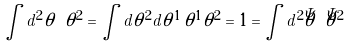<formula> <loc_0><loc_0><loc_500><loc_500>\int d ^ { 2 } \theta \ \theta ^ { 2 } = \int d \theta ^ { 2 } d \theta ^ { 1 } \, \theta ^ { 1 } \theta ^ { 2 } = 1 = \int d ^ { 2 } \bar { \theta } \ \bar { \theta } ^ { 2 }</formula> 